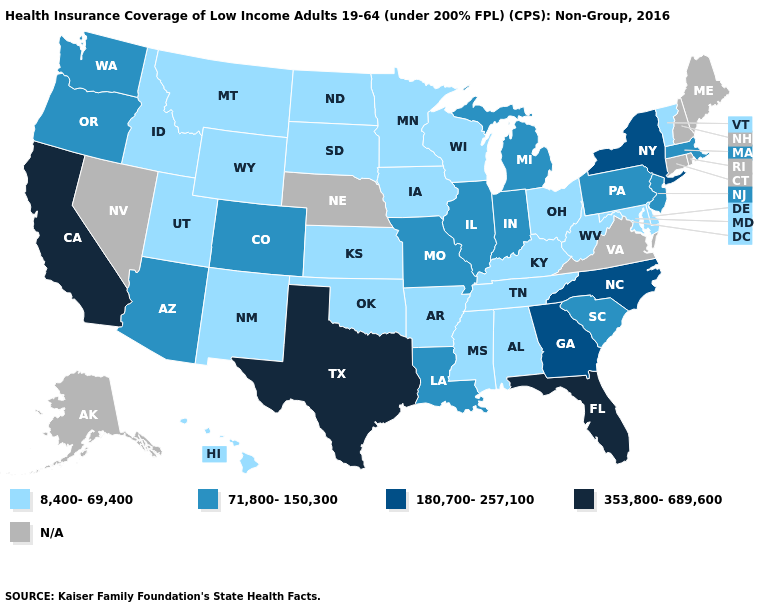What is the value of Tennessee?
Quick response, please. 8,400-69,400. Name the states that have a value in the range 180,700-257,100?
Write a very short answer. Georgia, New York, North Carolina. What is the value of North Dakota?
Quick response, please. 8,400-69,400. Among the states that border Oregon , does California have the lowest value?
Concise answer only. No. Name the states that have a value in the range 353,800-689,600?
Quick response, please. California, Florida, Texas. What is the highest value in states that border Missouri?
Answer briefly. 71,800-150,300. Is the legend a continuous bar?
Concise answer only. No. Among the states that border Utah , which have the highest value?
Be succinct. Arizona, Colorado. Name the states that have a value in the range 180,700-257,100?
Concise answer only. Georgia, New York, North Carolina. Name the states that have a value in the range 180,700-257,100?
Short answer required. Georgia, New York, North Carolina. Does Vermont have the lowest value in the Northeast?
Give a very brief answer. Yes. Does Georgia have the lowest value in the USA?
Write a very short answer. No. Name the states that have a value in the range 353,800-689,600?
Keep it brief. California, Florida, Texas. Does Michigan have the highest value in the MidWest?
Keep it brief. Yes. 